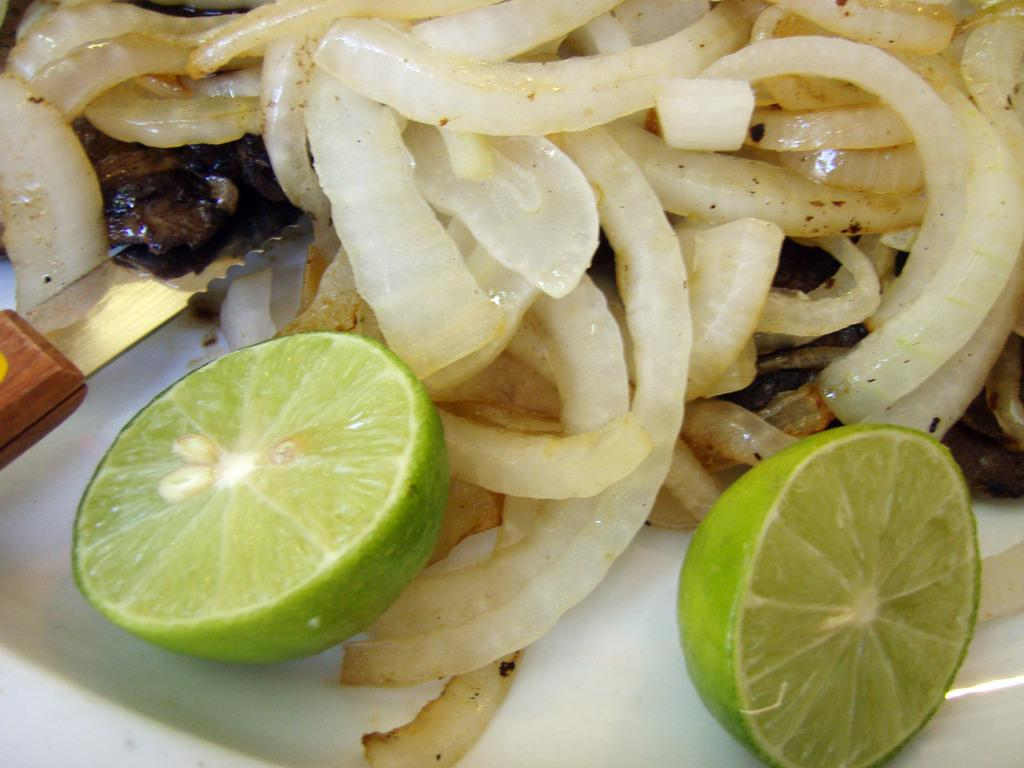What type of items are present in the image? The image consists of food. Can you identify any specific food items in the image? Yes, there are onions and a lemon in the image. What object is used for cutting in the image? There is a knife in the image. Where is the knife placed in the image? The knife is kept in a plate. What type of instrument is being played in the image? There is no instrument being played in the image; it only contains food items, a knife, and a plate. Can you see any animals on a farm in the image? There are no animals or farms present in the image; it consists of food items, a knife, and a plate. 